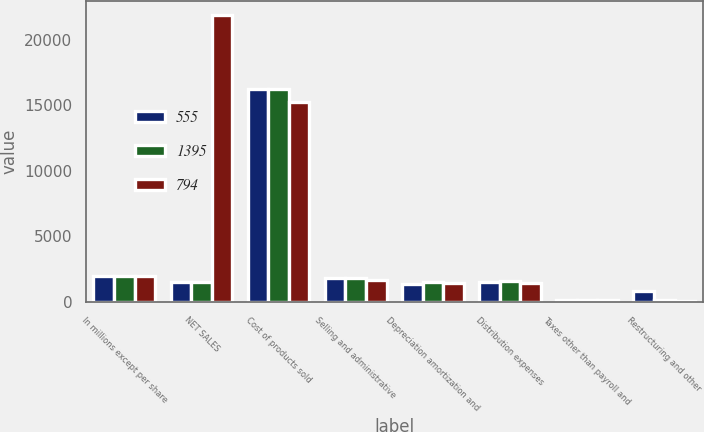<chart> <loc_0><loc_0><loc_500><loc_500><stacked_bar_chart><ecel><fcel>In millions except per share<fcel>NET SALES<fcel>Cost of products sold<fcel>Selling and administrative<fcel>Depreciation amortization and<fcel>Distribution expenses<fcel>Taxes other than payroll and<fcel>Restructuring and other<nl><fcel>555<fcel>2014<fcel>1557<fcel>16254<fcel>1793<fcel>1406<fcel>1521<fcel>180<fcel>846<nl><fcel>1395<fcel>2013<fcel>1557<fcel>16282<fcel>1796<fcel>1531<fcel>1583<fcel>178<fcel>156<nl><fcel>794<fcel>2012<fcel>21852<fcel>15287<fcel>1674<fcel>1473<fcel>1470<fcel>159<fcel>65<nl></chart> 